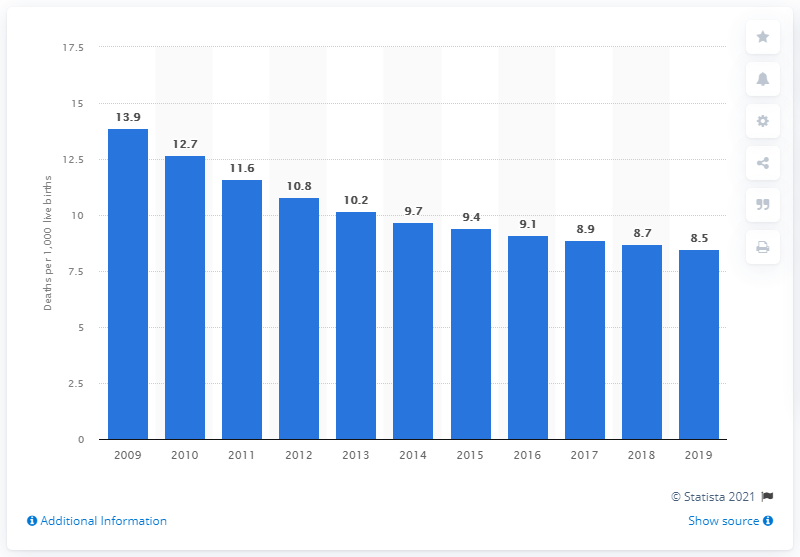Draw attention to some important aspects in this diagram. In 2019, the infant mortality rate in Georgia was 8.5 deaths per 1,000 live births. 